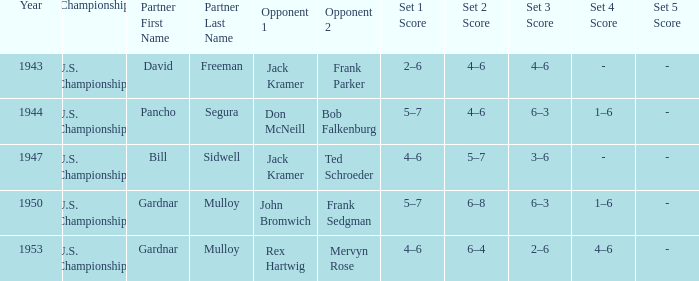Which Championship has a Score of 2–6, 4–6, 4–6? U.S. Championships. 